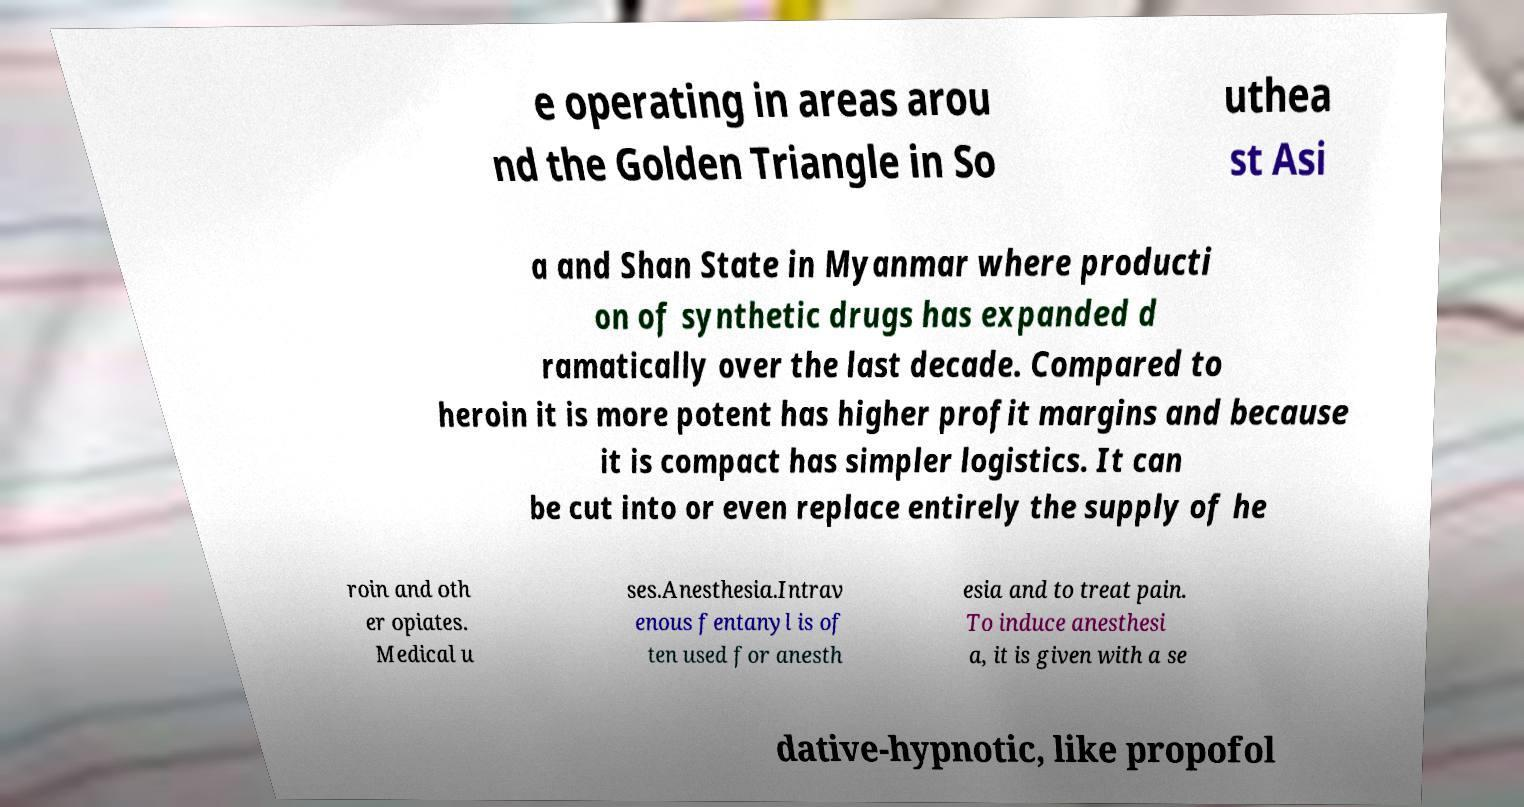Can you accurately transcribe the text from the provided image for me? e operating in areas arou nd the Golden Triangle in So uthea st Asi a and Shan State in Myanmar where producti on of synthetic drugs has expanded d ramatically over the last decade. Compared to heroin it is more potent has higher profit margins and because it is compact has simpler logistics. It can be cut into or even replace entirely the supply of he roin and oth er opiates. Medical u ses.Anesthesia.Intrav enous fentanyl is of ten used for anesth esia and to treat pain. To induce anesthesi a, it is given with a se dative-hypnotic, like propofol 